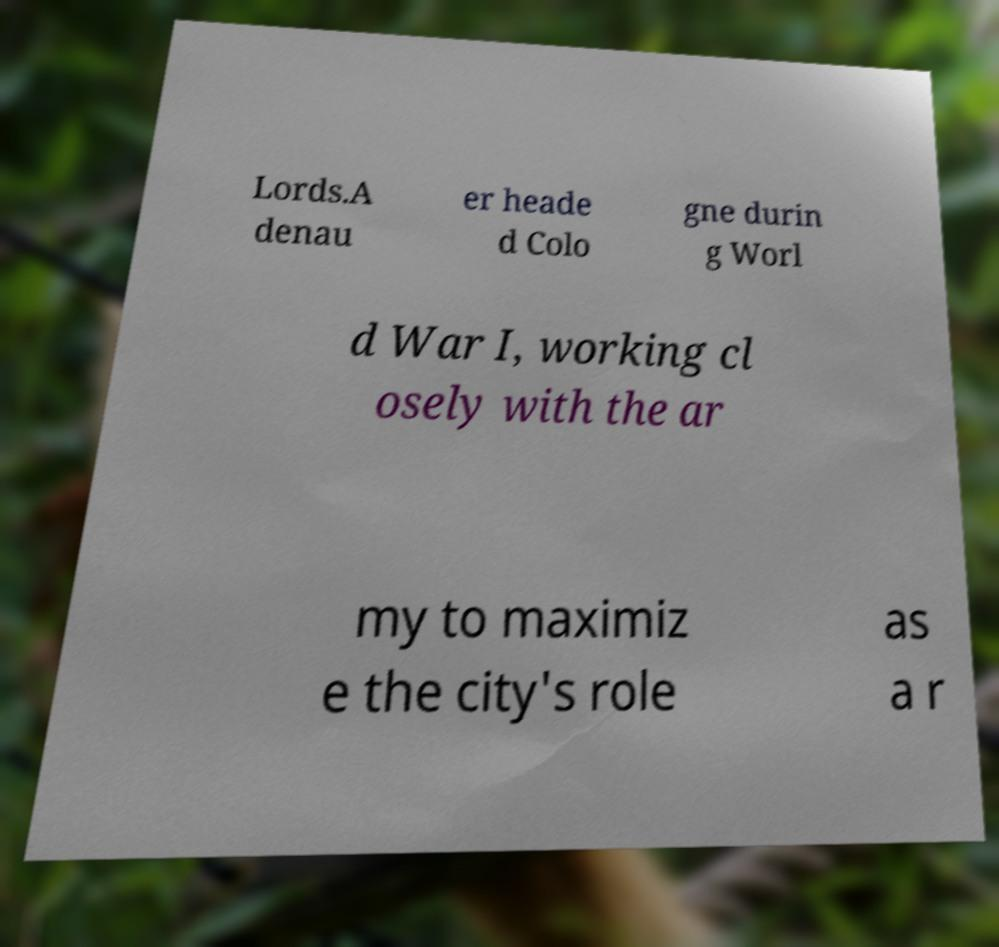Can you accurately transcribe the text from the provided image for me? Lords.A denau er heade d Colo gne durin g Worl d War I, working cl osely with the ar my to maximiz e the city's role as a r 